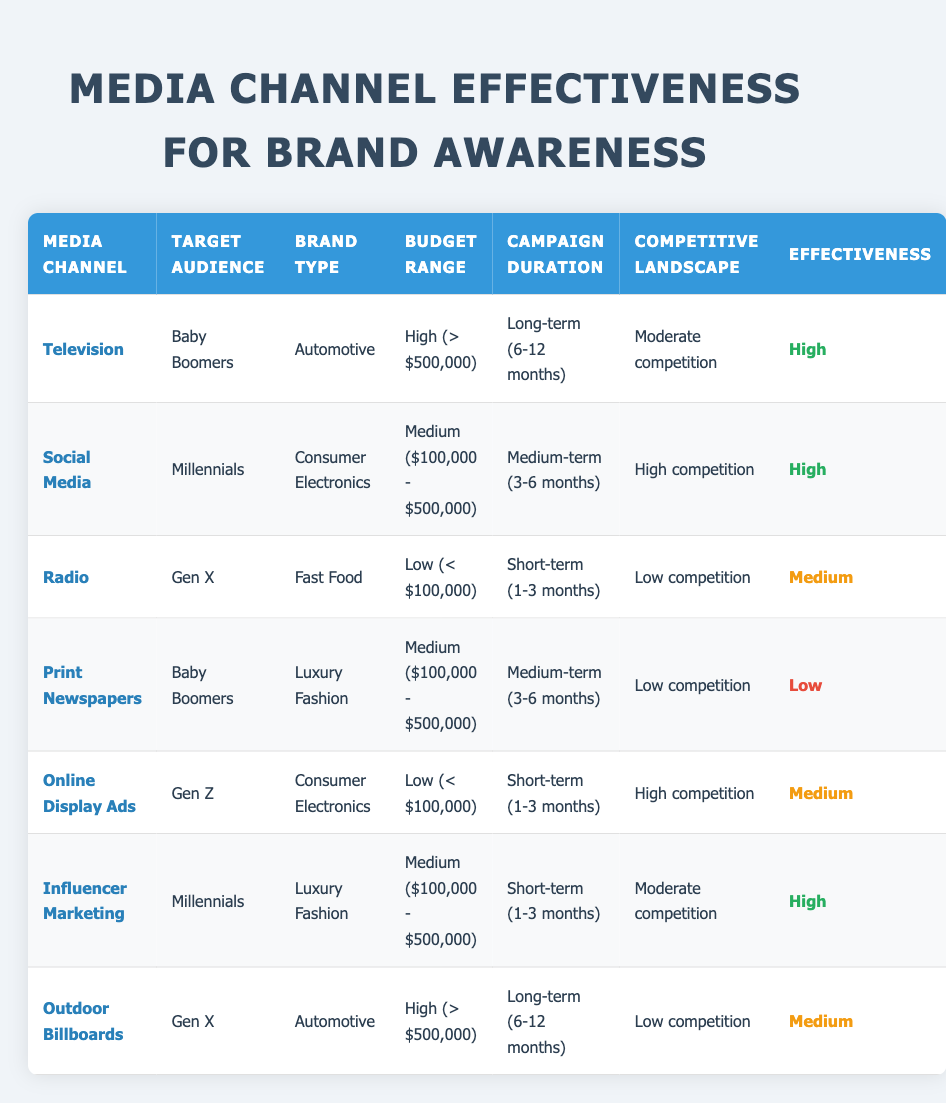What is the effectiveness rating for Television when targeting Baby Boomers in the Automotive brand type? From the table, the row corresponding to Television indicates it targets Baby Boomers in the Automotive brand type with a high budget and long-term campaign duration. The effectiveness column shows that this combination has a rating of "High."
Answer: High Which media channel has the highest effectiveness rating for Millennials? The table shows two media channels targeting Millennials: Social Media and Influencer Marketing. Both have a High effectiveness rating, but Social Media is first in the table, so it also has the highest effectiveness rating.
Answer: High How many media channels are listed with a Medium effectiveness rating? Scanning the table, I find Radio, Online Display Ads, and Outdoor Billboards each have a Medium effectiveness rating. Therefore, there are three media channels in total that fall into this category.
Answer: Three Is the effectiveness of Print Newspapers targeted at Baby Boomers for Luxury Fashion high? Referring to the table, Print Newspapers targeting Baby Boomers in Luxury Fashion shows a Low effectiveness rating, making the statement that it is high false.
Answer: No Which budget range corresponds to the highest effectiveness rating in the Automotive brand type? Evaluating the table, only the Television and Outdoor Billboards media channels impact the Automotive brand type. Television (High budget) has a High effectiveness rating, while Outdoor Billboards (High budget) has a Medium rating. Thus, High budget leads to High effectiveness with Television.
Answer: High What is the total number of media channels that focus on the Luxury Fashion brand type? The table features two media channels focusing on Luxury Fashion: Print Newspapers and Influencer Marketing. Counting these, we conclude that there are two media channels specifically targeting Luxury Fashion.
Answer: Two For the Online Display Ads targeting Gen Z, what is the effectiveness rating and the budget range? Looking at the table, Online Display Ads targeting Gen Z have a Medium effectiveness rating and a Low budget range (< $100,000).
Answer: Medium; Low What is the average effectiveness rating for the media channels targeting Gen X? The table shows two media channels focusing on Gen X: Radio (Medium effectiveness) and Outdoor Billboards (Medium effectiveness). Since both have the same rating, we calculate the average effectiveness as Medium.
Answer: Medium 